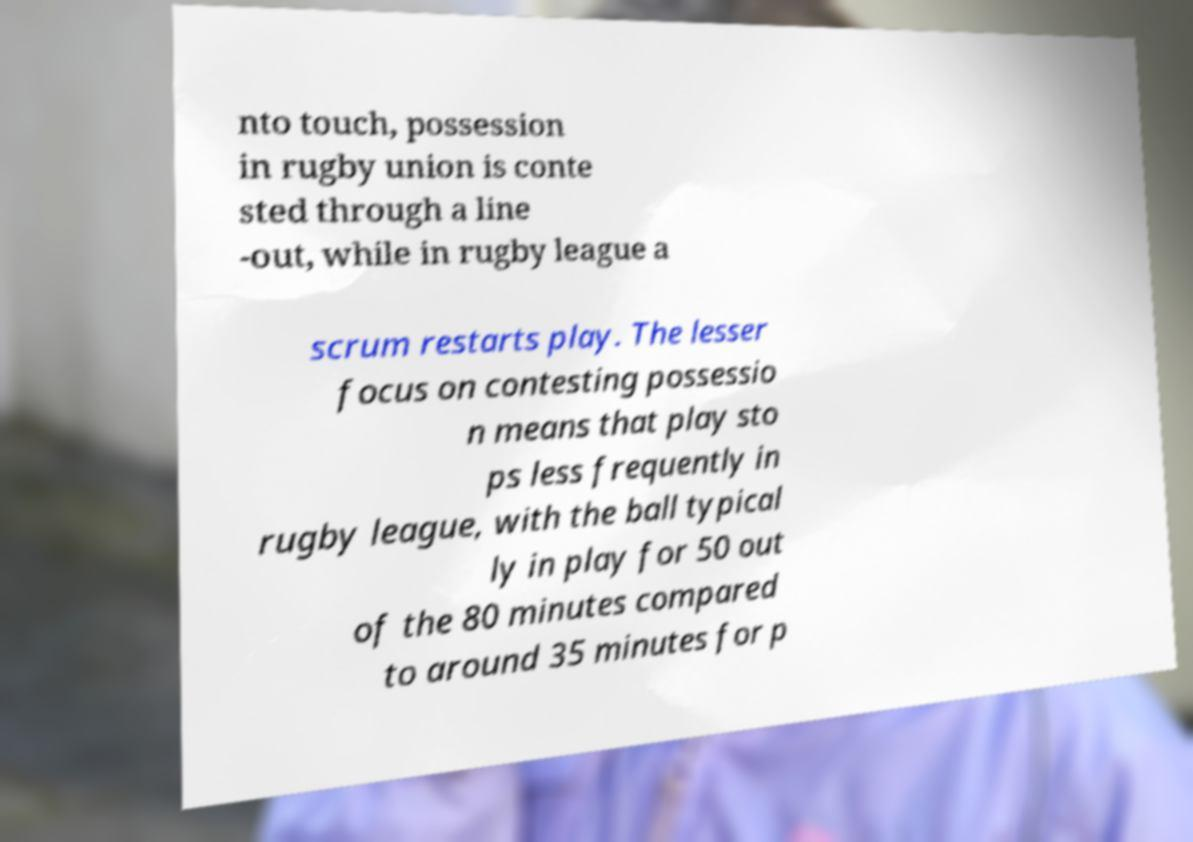Can you accurately transcribe the text from the provided image for me? nto touch, possession in rugby union is conte sted through a line -out, while in rugby league a scrum restarts play. The lesser focus on contesting possessio n means that play sto ps less frequently in rugby league, with the ball typical ly in play for 50 out of the 80 minutes compared to around 35 minutes for p 